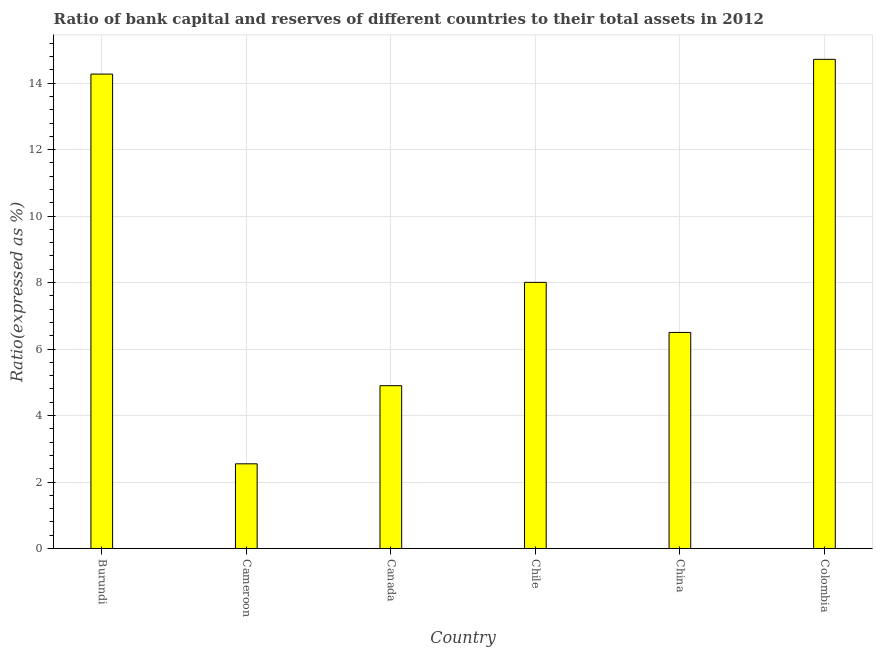Does the graph contain any zero values?
Make the answer very short. No. What is the title of the graph?
Keep it short and to the point. Ratio of bank capital and reserves of different countries to their total assets in 2012. What is the label or title of the X-axis?
Your answer should be compact. Country. What is the label or title of the Y-axis?
Your answer should be compact. Ratio(expressed as %). What is the bank capital to assets ratio in Burundi?
Your answer should be very brief. 14.27. Across all countries, what is the maximum bank capital to assets ratio?
Keep it short and to the point. 14.72. Across all countries, what is the minimum bank capital to assets ratio?
Ensure brevity in your answer.  2.55. In which country was the bank capital to assets ratio minimum?
Provide a short and direct response. Cameroon. What is the sum of the bank capital to assets ratio?
Ensure brevity in your answer.  50.94. What is the difference between the bank capital to assets ratio in Canada and Colombia?
Offer a very short reply. -9.82. What is the average bank capital to assets ratio per country?
Make the answer very short. 8.49. What is the median bank capital to assets ratio?
Ensure brevity in your answer.  7.25. What is the ratio of the bank capital to assets ratio in Cameroon to that in Chile?
Your response must be concise. 0.32. What is the difference between the highest and the second highest bank capital to assets ratio?
Your answer should be compact. 0.44. Is the sum of the bank capital to assets ratio in Burundi and Canada greater than the maximum bank capital to assets ratio across all countries?
Your response must be concise. Yes. What is the difference between the highest and the lowest bank capital to assets ratio?
Provide a succinct answer. 12.17. How many bars are there?
Your response must be concise. 6. How many countries are there in the graph?
Give a very brief answer. 6. Are the values on the major ticks of Y-axis written in scientific E-notation?
Offer a very short reply. No. What is the Ratio(expressed as %) in Burundi?
Your response must be concise. 14.27. What is the Ratio(expressed as %) in Cameroon?
Make the answer very short. 2.55. What is the Ratio(expressed as %) of Canada?
Provide a succinct answer. 4.9. What is the Ratio(expressed as %) of Chile?
Make the answer very short. 8.01. What is the Ratio(expressed as %) in Colombia?
Provide a succinct answer. 14.72. What is the difference between the Ratio(expressed as %) in Burundi and Cameroon?
Give a very brief answer. 11.73. What is the difference between the Ratio(expressed as %) in Burundi and Canada?
Keep it short and to the point. 9.37. What is the difference between the Ratio(expressed as %) in Burundi and Chile?
Offer a very short reply. 6.27. What is the difference between the Ratio(expressed as %) in Burundi and China?
Offer a terse response. 7.77. What is the difference between the Ratio(expressed as %) in Burundi and Colombia?
Your answer should be very brief. -0.44. What is the difference between the Ratio(expressed as %) in Cameroon and Canada?
Make the answer very short. -2.35. What is the difference between the Ratio(expressed as %) in Cameroon and Chile?
Give a very brief answer. -5.46. What is the difference between the Ratio(expressed as %) in Cameroon and China?
Ensure brevity in your answer.  -3.95. What is the difference between the Ratio(expressed as %) in Cameroon and Colombia?
Offer a very short reply. -12.17. What is the difference between the Ratio(expressed as %) in Canada and Chile?
Give a very brief answer. -3.11. What is the difference between the Ratio(expressed as %) in Canada and China?
Ensure brevity in your answer.  -1.6. What is the difference between the Ratio(expressed as %) in Canada and Colombia?
Keep it short and to the point. -9.82. What is the difference between the Ratio(expressed as %) in Chile and China?
Make the answer very short. 1.51. What is the difference between the Ratio(expressed as %) in Chile and Colombia?
Your answer should be very brief. -6.71. What is the difference between the Ratio(expressed as %) in China and Colombia?
Offer a terse response. -8.22. What is the ratio of the Ratio(expressed as %) in Burundi to that in Cameroon?
Offer a very short reply. 5.6. What is the ratio of the Ratio(expressed as %) in Burundi to that in Canada?
Give a very brief answer. 2.91. What is the ratio of the Ratio(expressed as %) in Burundi to that in Chile?
Your response must be concise. 1.78. What is the ratio of the Ratio(expressed as %) in Burundi to that in China?
Offer a terse response. 2.2. What is the ratio of the Ratio(expressed as %) in Burundi to that in Colombia?
Your response must be concise. 0.97. What is the ratio of the Ratio(expressed as %) in Cameroon to that in Canada?
Provide a short and direct response. 0.52. What is the ratio of the Ratio(expressed as %) in Cameroon to that in Chile?
Provide a succinct answer. 0.32. What is the ratio of the Ratio(expressed as %) in Cameroon to that in China?
Provide a succinct answer. 0.39. What is the ratio of the Ratio(expressed as %) in Cameroon to that in Colombia?
Ensure brevity in your answer.  0.17. What is the ratio of the Ratio(expressed as %) in Canada to that in Chile?
Your answer should be very brief. 0.61. What is the ratio of the Ratio(expressed as %) in Canada to that in China?
Keep it short and to the point. 0.75. What is the ratio of the Ratio(expressed as %) in Canada to that in Colombia?
Give a very brief answer. 0.33. What is the ratio of the Ratio(expressed as %) in Chile to that in China?
Ensure brevity in your answer.  1.23. What is the ratio of the Ratio(expressed as %) in Chile to that in Colombia?
Provide a short and direct response. 0.54. What is the ratio of the Ratio(expressed as %) in China to that in Colombia?
Offer a terse response. 0.44. 